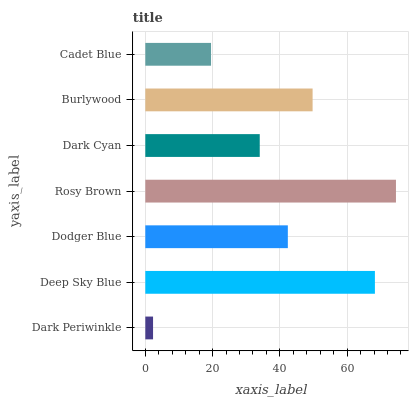Is Dark Periwinkle the minimum?
Answer yes or no. Yes. Is Rosy Brown the maximum?
Answer yes or no. Yes. Is Deep Sky Blue the minimum?
Answer yes or no. No. Is Deep Sky Blue the maximum?
Answer yes or no. No. Is Deep Sky Blue greater than Dark Periwinkle?
Answer yes or no. Yes. Is Dark Periwinkle less than Deep Sky Blue?
Answer yes or no. Yes. Is Dark Periwinkle greater than Deep Sky Blue?
Answer yes or no. No. Is Deep Sky Blue less than Dark Periwinkle?
Answer yes or no. No. Is Dodger Blue the high median?
Answer yes or no. Yes. Is Dodger Blue the low median?
Answer yes or no. Yes. Is Cadet Blue the high median?
Answer yes or no. No. Is Dark Cyan the low median?
Answer yes or no. No. 